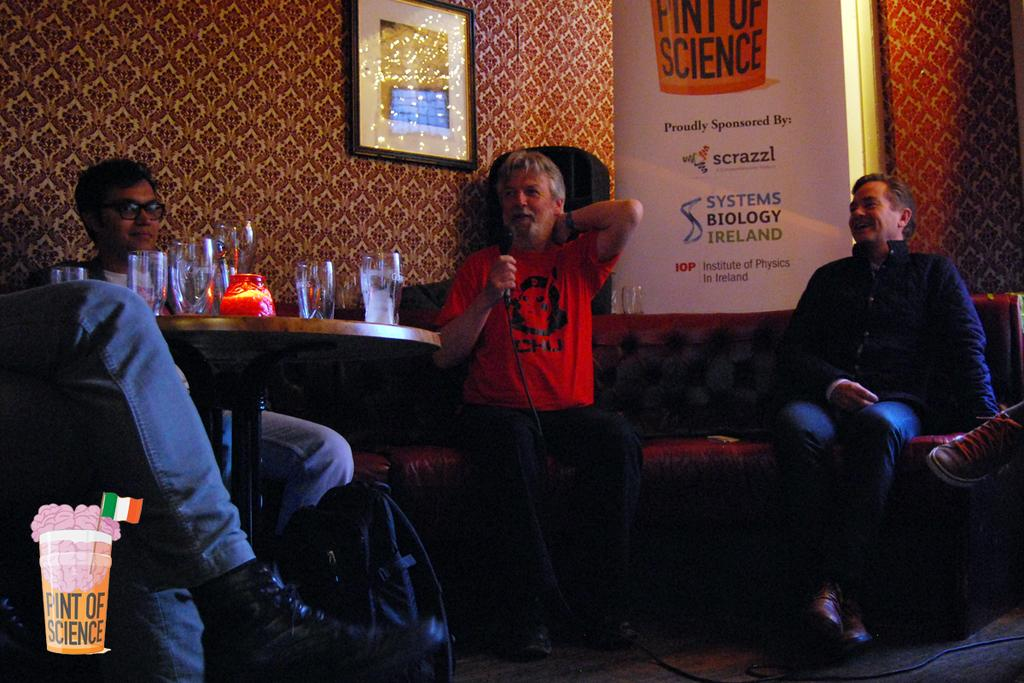How many people are in the image? There are three people in the image. What are the people doing in the image? The people are sitting on sofas. What is located in front of the sofas? There is a table in front of the sofas. What objects can be seen on the table? There are glasses on the table. What is one person holding in the image? One person is holding a microphone. What type of pancake is being served by the fireman in the image? There is no fireman or pancake present in the image. Can you see a squirrel sitting on the sofa with the people in the image? There is no squirrel present in the image; only the three people are visible. 